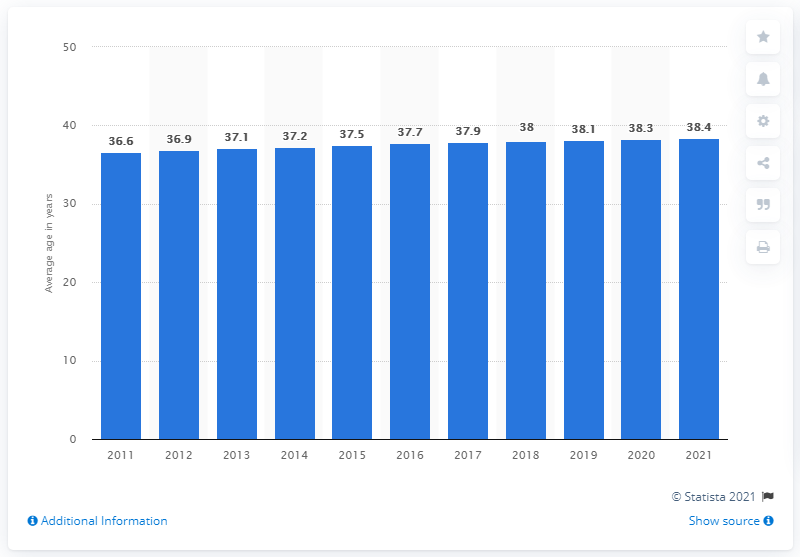List a handful of essential elements in this visual. In 2021, the average age of the Icelandic population was 38.4 years. 